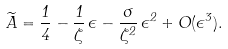<formula> <loc_0><loc_0><loc_500><loc_500>\widetilde { A } = \frac { 1 } { 4 } - \frac { 1 } { \zeta } \, \epsilon - \frac { \sigma } { \zeta ^ { 2 } } \, \epsilon ^ { 2 } + O ( \epsilon ^ { 3 } ) .</formula> 